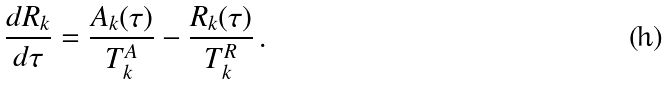Convert formula to latex. <formula><loc_0><loc_0><loc_500><loc_500>\frac { d R _ { k } } { d \tau } = \frac { A _ { k } ( \tau ) } { T _ { k } ^ { A } } - \frac { R _ { k } ( \tau ) } { T _ { k } ^ { R } } \, .</formula> 